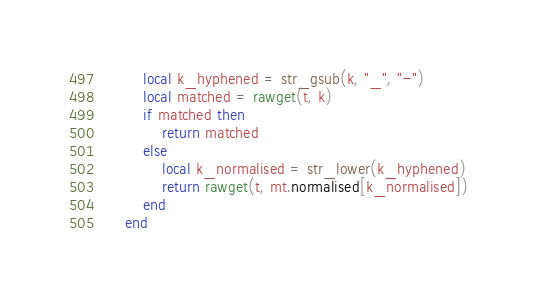Convert code to text. <code><loc_0><loc_0><loc_500><loc_500><_Lua_>        local k_hyphened = str_gsub(k, "_", "-")
        local matched = rawget(t, k)
        if matched then
            return matched
        else
            local k_normalised = str_lower(k_hyphened)
            return rawget(t, mt.normalised[k_normalised])
        end
    end

</code> 